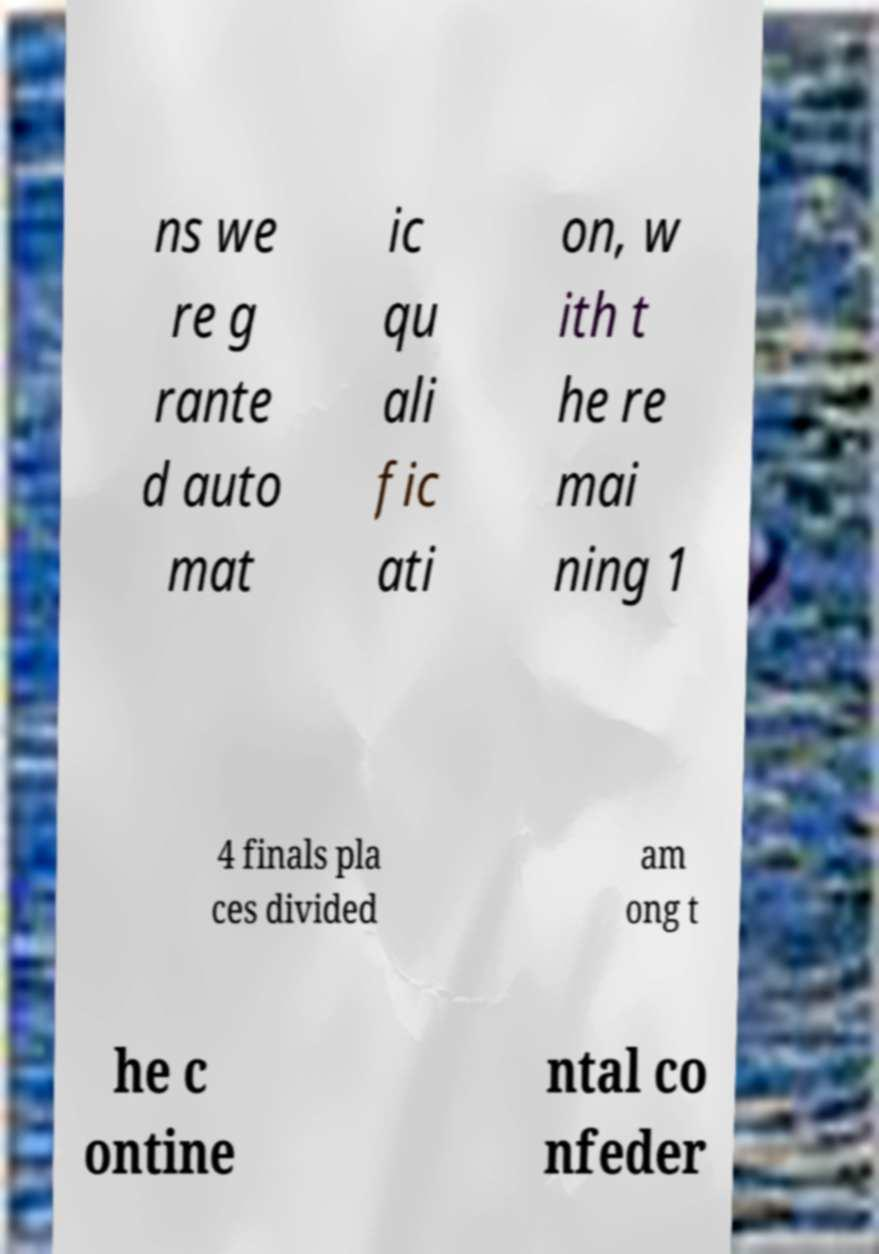Please identify and transcribe the text found in this image. ns we re g rante d auto mat ic qu ali fic ati on, w ith t he re mai ning 1 4 finals pla ces divided am ong t he c ontine ntal co nfeder 